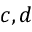<formula> <loc_0><loc_0><loc_500><loc_500>c , d</formula> 